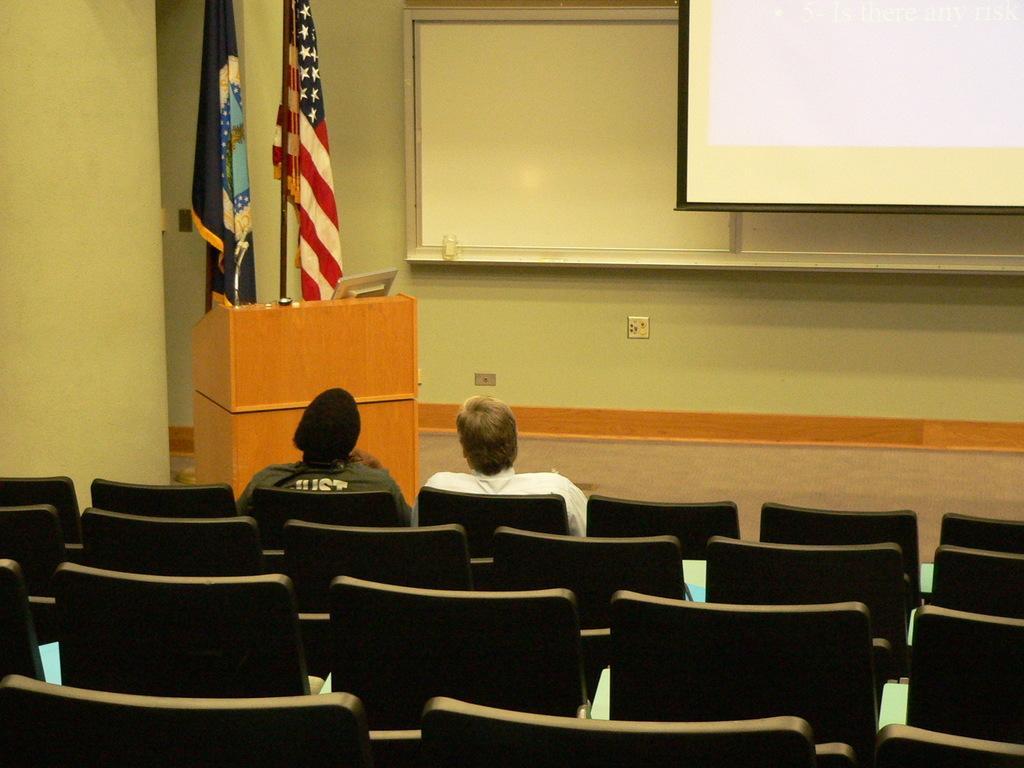Please provide a concise description of this image. In this image there are chairs. There are two people sitting on the chairs. In front of them there is a dais. There is a podium on the dais. On the podium there is a laptop. Behind the podium there are flags to the poles. In the background there is the wall. In the top right there is a projector board. 